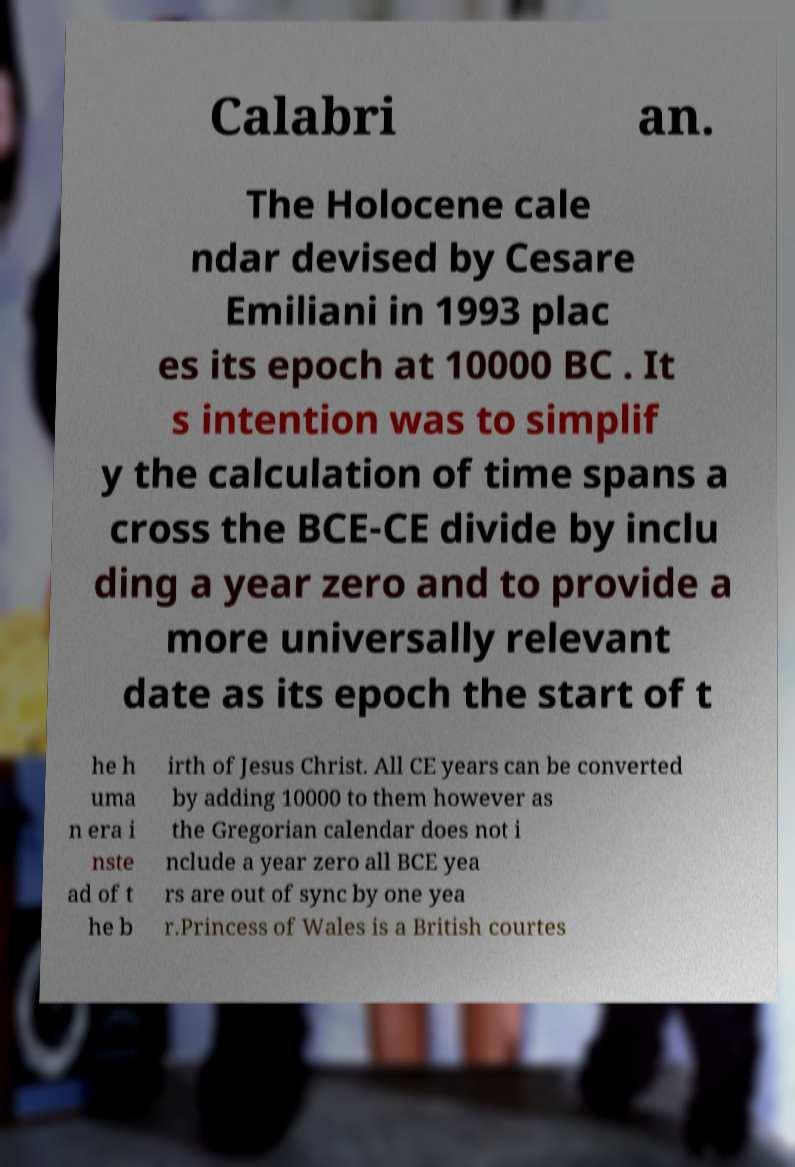Can you accurately transcribe the text from the provided image for me? Calabri an. The Holocene cale ndar devised by Cesare Emiliani in 1993 plac es its epoch at 10000 BC . It s intention was to simplif y the calculation of time spans a cross the BCE-CE divide by inclu ding a year zero and to provide a more universally relevant date as its epoch the start of t he h uma n era i nste ad of t he b irth of Jesus Christ. All CE years can be converted by adding 10000 to them however as the Gregorian calendar does not i nclude a year zero all BCE yea rs are out of sync by one yea r.Princess of Wales is a British courtes 